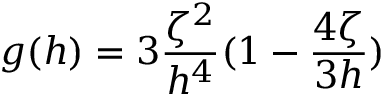Convert formula to latex. <formula><loc_0><loc_0><loc_500><loc_500>g ( h ) = 3 \frac { \zeta ^ { 2 } } { h ^ { 4 } } ( 1 - \frac { 4 \zeta } { 3 h } )</formula> 